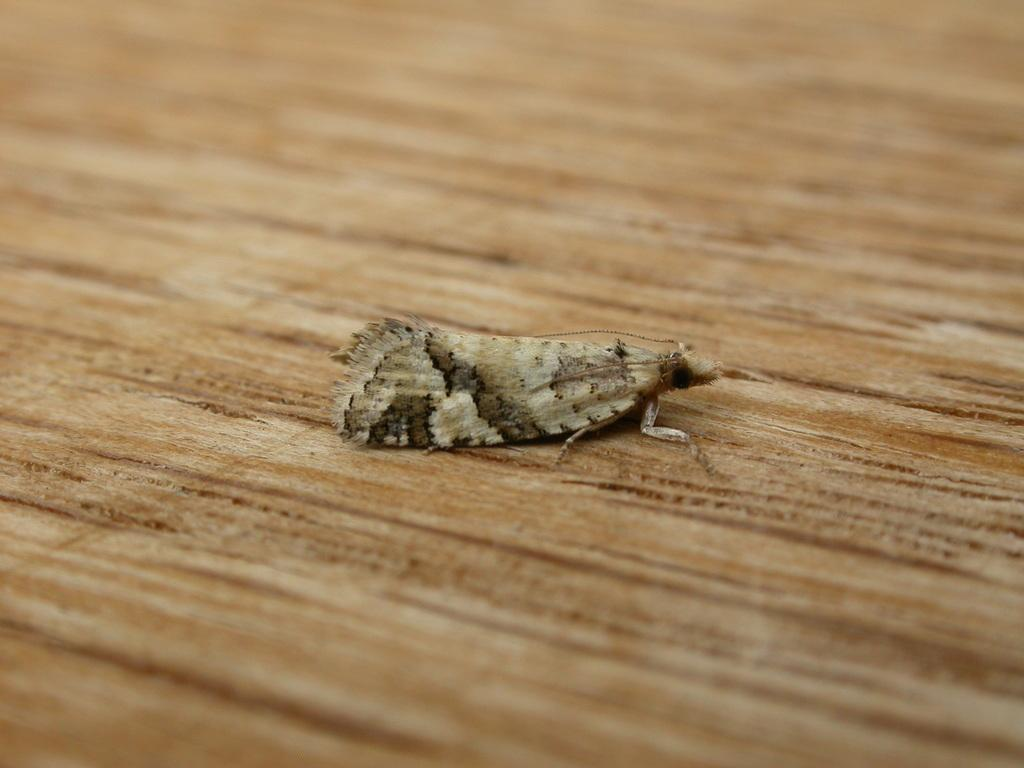What type of creature is present in the image? There is an insect in the image. What surface is the insect on? The insect is on wood. How many bags does the insect have in the image? There are no bags present in the image; it features an insect on wood. What type of legs does the insect have in the image? The insect has legs, but the specific type of legs cannot be determined from the image alone. 